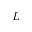<formula> <loc_0><loc_0><loc_500><loc_500>L</formula> 